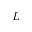<formula> <loc_0><loc_0><loc_500><loc_500>L</formula> 